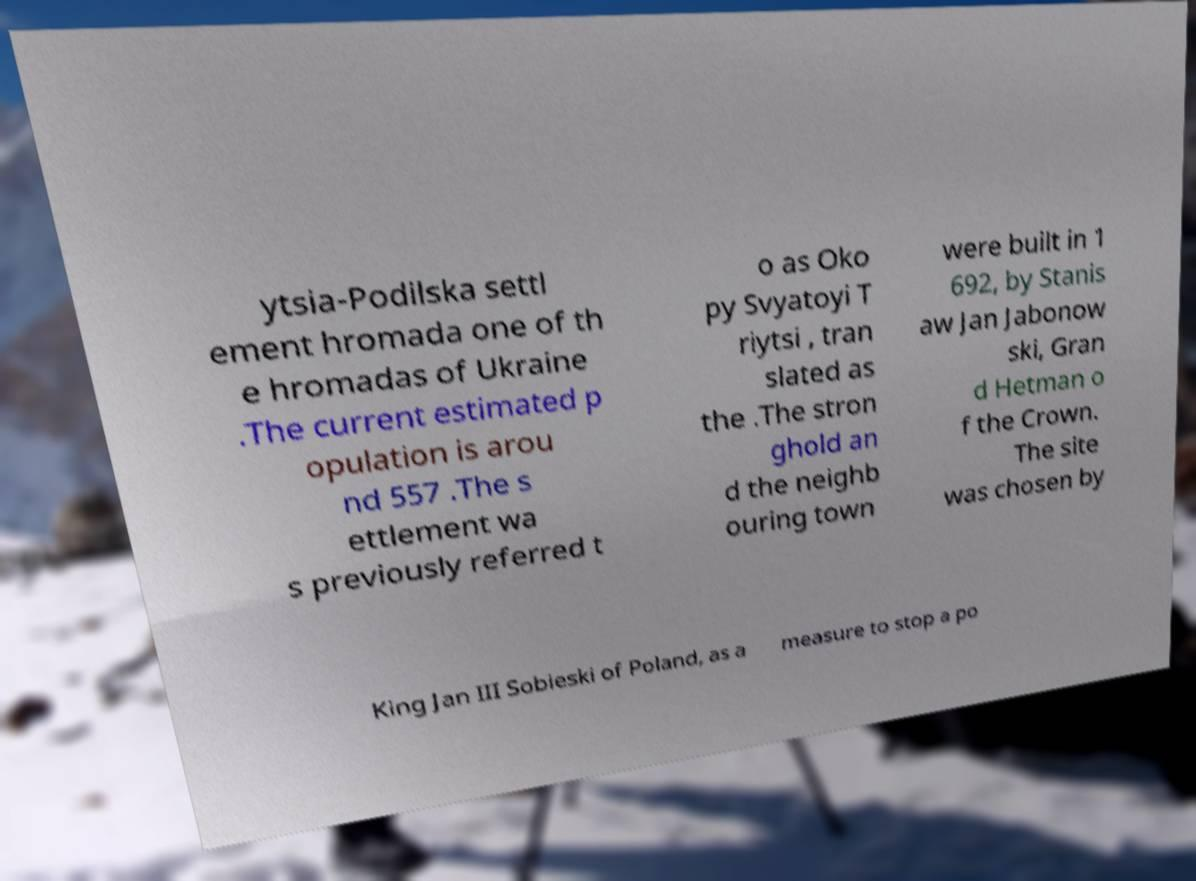Can you accurately transcribe the text from the provided image for me? ytsia-Podilska settl ement hromada one of th e hromadas of Ukraine .The current estimated p opulation is arou nd 557 .The s ettlement wa s previously referred t o as Oko py Svyatoyi T riytsi , tran slated as the .The stron ghold an d the neighb ouring town were built in 1 692, by Stanis aw Jan Jabonow ski, Gran d Hetman o f the Crown. The site was chosen by King Jan III Sobieski of Poland, as a measure to stop a po 